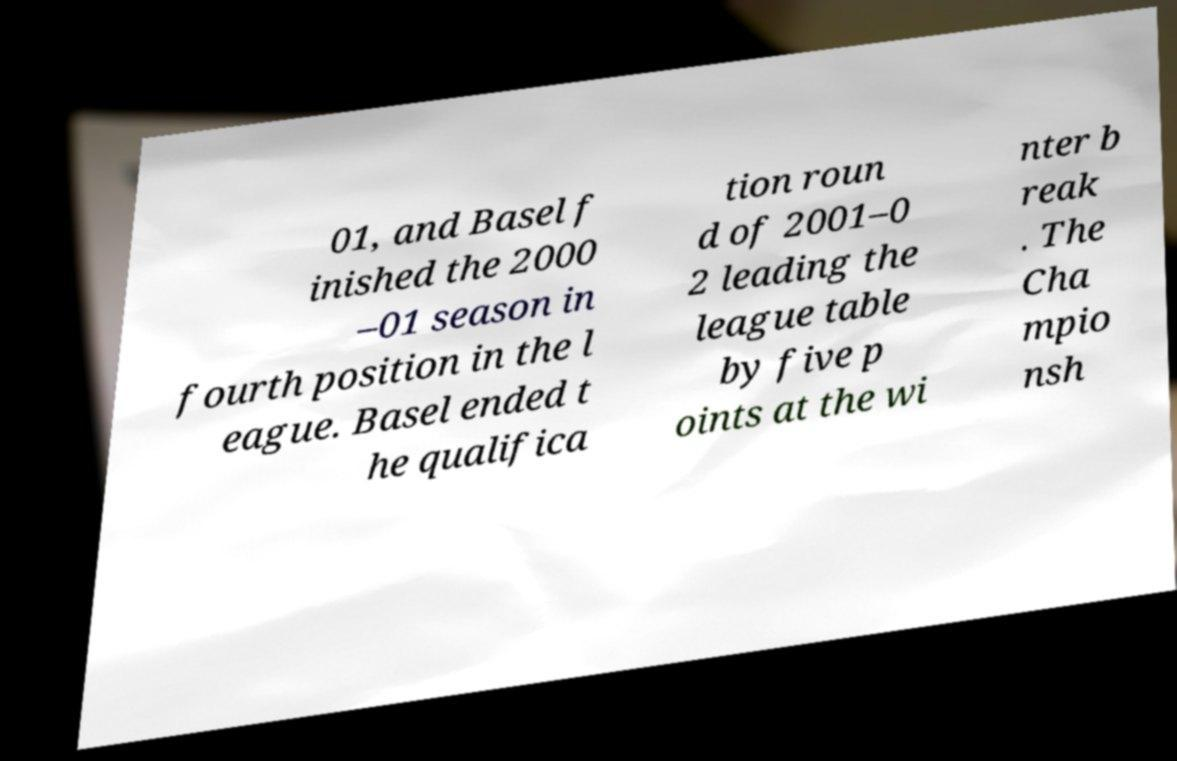Please read and relay the text visible in this image. What does it say? 01, and Basel f inished the 2000 –01 season in fourth position in the l eague. Basel ended t he qualifica tion roun d of 2001–0 2 leading the league table by five p oints at the wi nter b reak . The Cha mpio nsh 